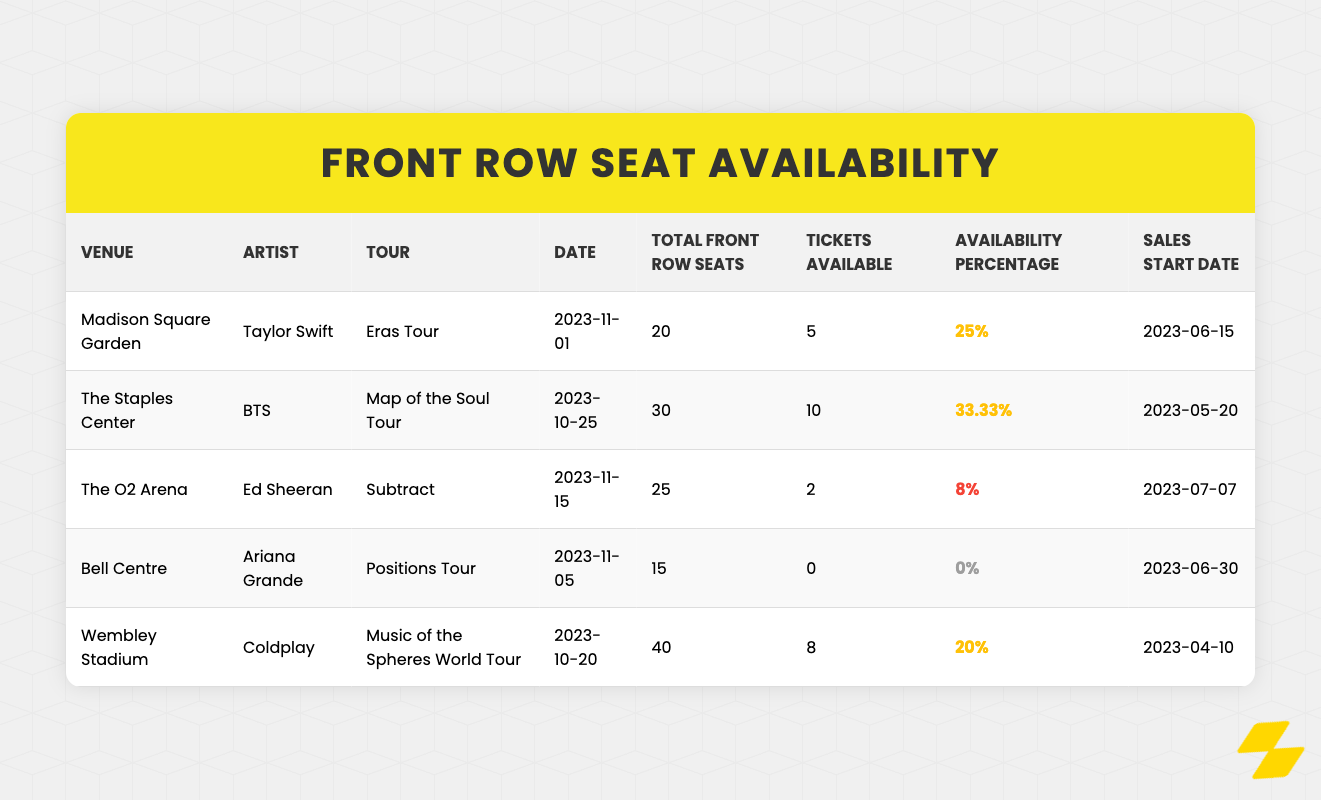What is the total number of front row seats available for Taylor Swift's concert at Madison Square Garden? Referring to the table, it shows that the total front row seats for Taylor Swift at Madison Square Garden is 20.
Answer: 20 Which artist has the highest percentage of tickets available? Looking at the availability percentage column, BTS has the highest availability percentage at 33.33%.
Answer: BTS How many concerts have sold out front row seats? By checking the table, only Ariana Grande's concert at Bell Centre shows 0 tickets available, indicating it is sold out. Therefore, there is 1 concert sold out.
Answer: 1 What is the total number of tickets available across all concerts listed? Adding the tickets available for each concert: 5 (Taylor Swift) + 10 (BTS) + 2 (Ed Sheeran) + 0 (Ariana Grande) + 8 (Coldplay) = 25 tickets available.
Answer: 25 Is Coldplay's concert at Wembley Stadium selling out fast? Comparing the availability percentage, Coldplay has 20% availability, which is not very low, indicating it is not selling out fast.
Answer: No Which venue has the least availability percentage among the concerts listed? The O2 Arena has the least availability percentage at 8%, as shown in the table.
Answer: The O2 Arena What is the difference in the total front row seats between the concert of Ed Sheeran and that of Coldplay? Calculating the difference: Coldplay has 40 total front row seats and Ed Sheeran has 25. Thus, 40 - 25 = 15 front row seats more for Coldplay.
Answer: 15 How many artists have front row tickets with availability less than 10%? Looking closely at the tickets available, Ed Sheeran (8%) and Ariana Grande (0%) are the only two artists with an availability percentage under 10%. Therefore, there are 2 artists.
Answer: 2 